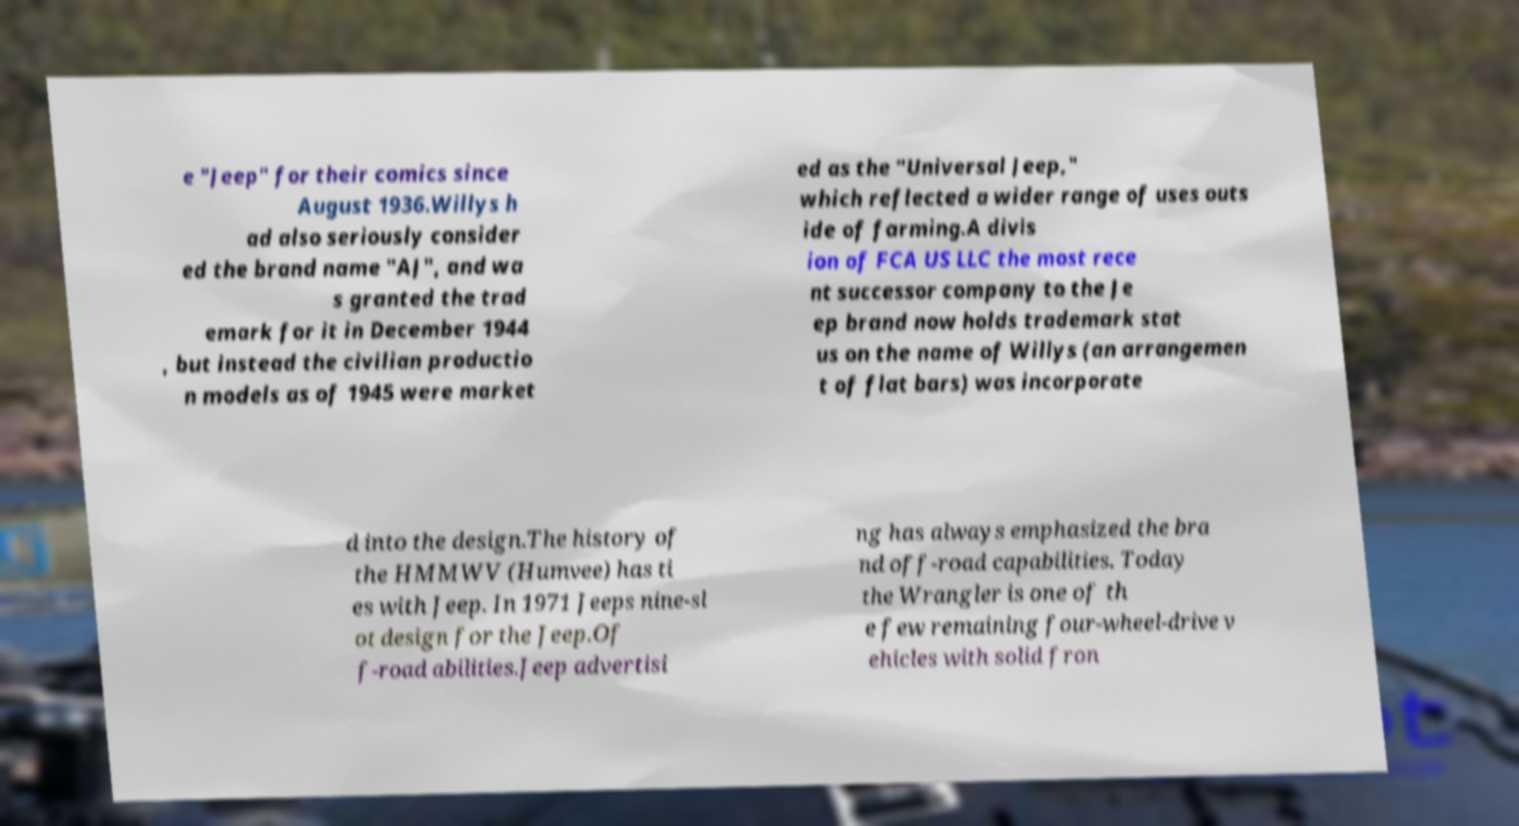Please read and relay the text visible in this image. What does it say? e "Jeep" for their comics since August 1936.Willys h ad also seriously consider ed the brand name "AJ", and wa s granted the trad emark for it in December 1944 , but instead the civilian productio n models as of 1945 were market ed as the "Universal Jeep," which reflected a wider range of uses outs ide of farming.A divis ion of FCA US LLC the most rece nt successor company to the Je ep brand now holds trademark stat us on the name of Willys (an arrangemen t of flat bars) was incorporate d into the design.The history of the HMMWV (Humvee) has ti es with Jeep. In 1971 Jeeps nine-sl ot design for the Jeep.Of f-road abilities.Jeep advertisi ng has always emphasized the bra nd off-road capabilities. Today the Wrangler is one of th e few remaining four-wheel-drive v ehicles with solid fron 